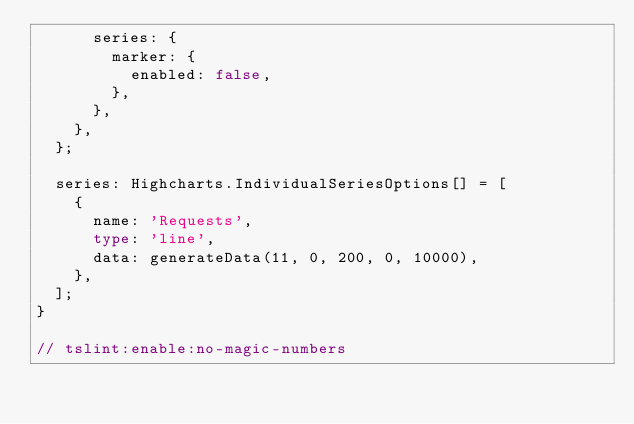Convert code to text. <code><loc_0><loc_0><loc_500><loc_500><_TypeScript_>      series: {
        marker: {
          enabled: false,
        },
      },
    },
  };

  series: Highcharts.IndividualSeriesOptions[] = [
    {
      name: 'Requests',
      type: 'line',
      data: generateData(11, 0, 200, 0, 10000),
    },
  ];
}

// tslint:enable:no-magic-numbers
</code> 